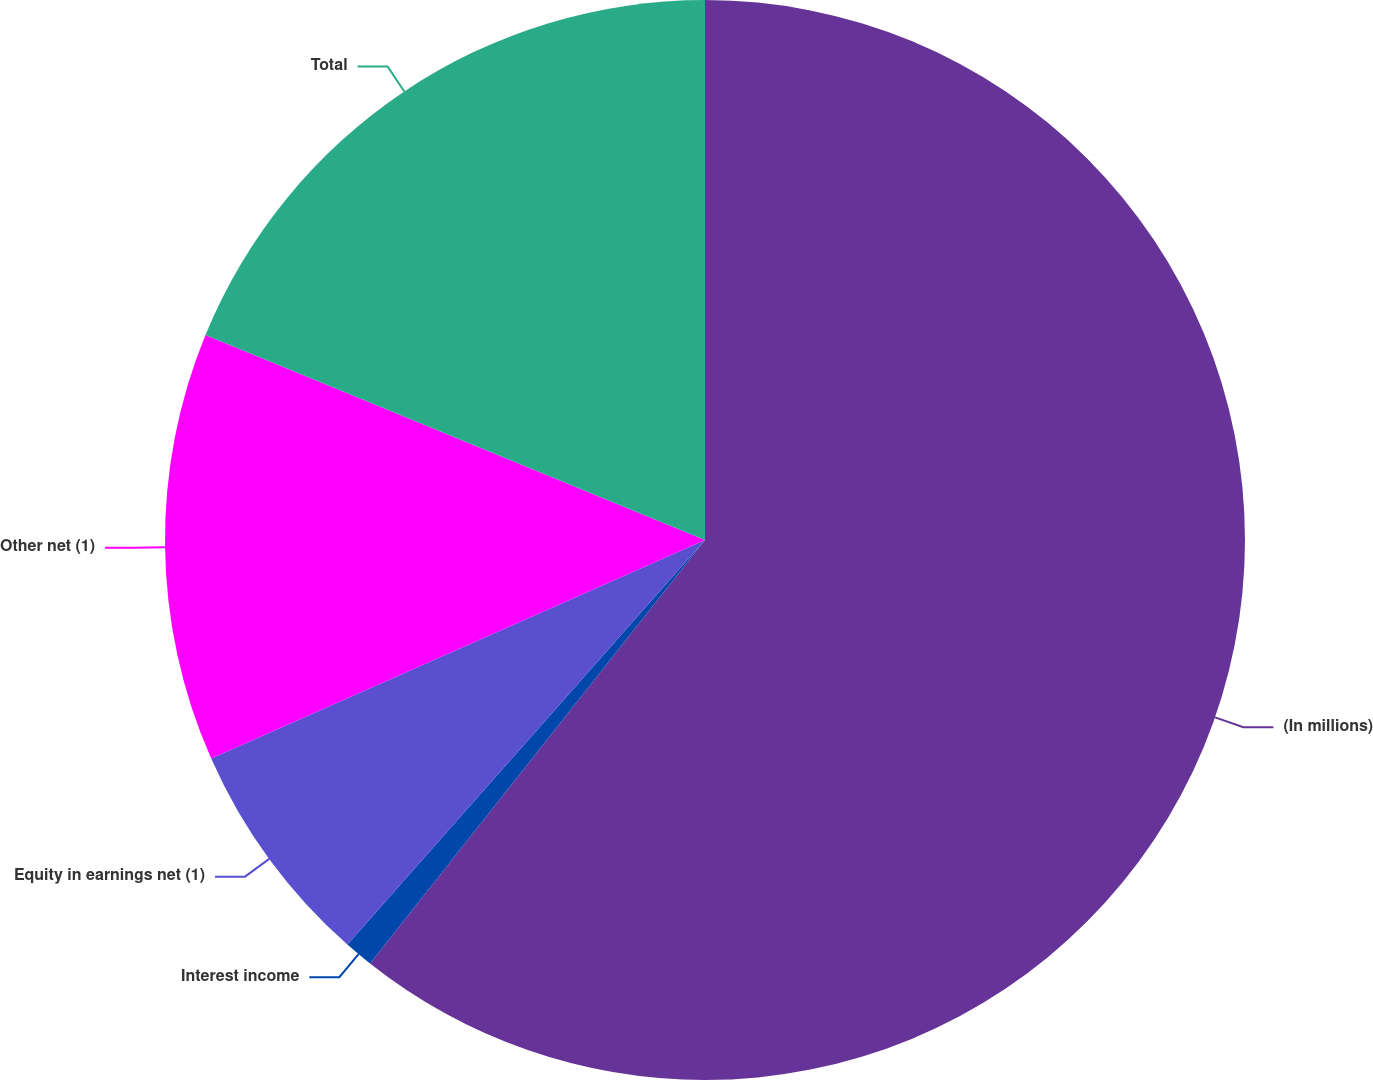<chart> <loc_0><loc_0><loc_500><loc_500><pie_chart><fcel>(In millions)<fcel>Interest income<fcel>Equity in earnings net (1)<fcel>Other net (1)<fcel>Total<nl><fcel>60.65%<fcel>0.87%<fcel>6.85%<fcel>12.83%<fcel>18.8%<nl></chart> 